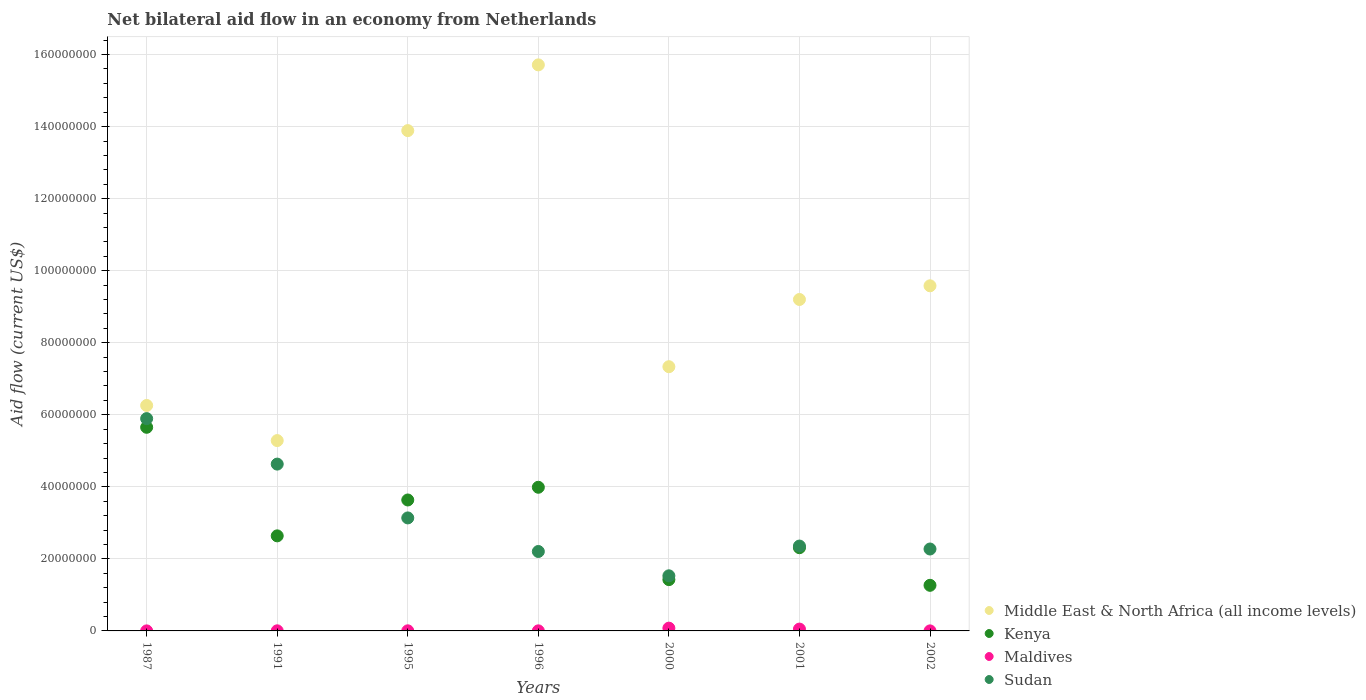How many different coloured dotlines are there?
Give a very brief answer. 4. What is the net bilateral aid flow in Sudan in 1995?
Give a very brief answer. 3.14e+07. Across all years, what is the maximum net bilateral aid flow in Maldives?
Your response must be concise. 7.70e+05. Across all years, what is the minimum net bilateral aid flow in Maldives?
Your answer should be very brief. 10000. What is the total net bilateral aid flow in Kenya in the graph?
Your response must be concise. 2.09e+08. What is the difference between the net bilateral aid flow in Middle East & North Africa (all income levels) in 1995 and that in 2002?
Keep it short and to the point. 4.31e+07. What is the difference between the net bilateral aid flow in Maldives in 2002 and the net bilateral aid flow in Sudan in 2001?
Your answer should be very brief. -2.36e+07. What is the average net bilateral aid flow in Sudan per year?
Your response must be concise. 3.15e+07. In the year 1987, what is the difference between the net bilateral aid flow in Sudan and net bilateral aid flow in Middle East & North Africa (all income levels)?
Provide a succinct answer. -3.65e+06. What is the ratio of the net bilateral aid flow in Middle East & North Africa (all income levels) in 1995 to that in 1996?
Ensure brevity in your answer.  0.88. Is the net bilateral aid flow in Sudan in 1987 less than that in 2002?
Keep it short and to the point. No. Is the difference between the net bilateral aid flow in Sudan in 1991 and 2000 greater than the difference between the net bilateral aid flow in Middle East & North Africa (all income levels) in 1991 and 2000?
Your answer should be very brief. Yes. What is the difference between the highest and the second highest net bilateral aid flow in Middle East & North Africa (all income levels)?
Keep it short and to the point. 1.82e+07. What is the difference between the highest and the lowest net bilateral aid flow in Middle East & North Africa (all income levels)?
Provide a short and direct response. 1.04e+08. Is it the case that in every year, the sum of the net bilateral aid flow in Kenya and net bilateral aid flow in Middle East & North Africa (all income levels)  is greater than the sum of net bilateral aid flow in Maldives and net bilateral aid flow in Sudan?
Provide a succinct answer. No. Is it the case that in every year, the sum of the net bilateral aid flow in Maldives and net bilateral aid flow in Kenya  is greater than the net bilateral aid flow in Sudan?
Ensure brevity in your answer.  No. Does the net bilateral aid flow in Kenya monotonically increase over the years?
Offer a terse response. No. Is the net bilateral aid flow in Kenya strictly less than the net bilateral aid flow in Maldives over the years?
Provide a succinct answer. No. Does the graph contain any zero values?
Provide a succinct answer. No. Where does the legend appear in the graph?
Make the answer very short. Bottom right. How many legend labels are there?
Your answer should be very brief. 4. What is the title of the graph?
Provide a short and direct response. Net bilateral aid flow in an economy from Netherlands. Does "Sudan" appear as one of the legend labels in the graph?
Ensure brevity in your answer.  Yes. What is the label or title of the X-axis?
Keep it short and to the point. Years. What is the Aid flow (current US$) of Middle East & North Africa (all income levels) in 1987?
Provide a short and direct response. 6.26e+07. What is the Aid flow (current US$) of Kenya in 1987?
Provide a short and direct response. 5.65e+07. What is the Aid flow (current US$) in Maldives in 1987?
Provide a short and direct response. 10000. What is the Aid flow (current US$) in Sudan in 1987?
Your answer should be compact. 5.89e+07. What is the Aid flow (current US$) of Middle East & North Africa (all income levels) in 1991?
Offer a terse response. 5.28e+07. What is the Aid flow (current US$) of Kenya in 1991?
Your answer should be compact. 2.64e+07. What is the Aid flow (current US$) of Sudan in 1991?
Make the answer very short. 4.63e+07. What is the Aid flow (current US$) of Middle East & North Africa (all income levels) in 1995?
Make the answer very short. 1.39e+08. What is the Aid flow (current US$) of Kenya in 1995?
Your answer should be compact. 3.64e+07. What is the Aid flow (current US$) of Maldives in 1995?
Provide a short and direct response. 3.00e+04. What is the Aid flow (current US$) in Sudan in 1995?
Provide a succinct answer. 3.14e+07. What is the Aid flow (current US$) in Middle East & North Africa (all income levels) in 1996?
Provide a succinct answer. 1.57e+08. What is the Aid flow (current US$) in Kenya in 1996?
Give a very brief answer. 3.99e+07. What is the Aid flow (current US$) in Maldives in 1996?
Give a very brief answer. 2.00e+04. What is the Aid flow (current US$) in Sudan in 1996?
Ensure brevity in your answer.  2.20e+07. What is the Aid flow (current US$) in Middle East & North Africa (all income levels) in 2000?
Offer a very short reply. 7.34e+07. What is the Aid flow (current US$) of Kenya in 2000?
Your answer should be very brief. 1.42e+07. What is the Aid flow (current US$) of Maldives in 2000?
Keep it short and to the point. 7.70e+05. What is the Aid flow (current US$) in Sudan in 2000?
Provide a succinct answer. 1.53e+07. What is the Aid flow (current US$) in Middle East & North Africa (all income levels) in 2001?
Your answer should be very brief. 9.20e+07. What is the Aid flow (current US$) in Kenya in 2001?
Ensure brevity in your answer.  2.31e+07. What is the Aid flow (current US$) of Maldives in 2001?
Keep it short and to the point. 5.10e+05. What is the Aid flow (current US$) of Sudan in 2001?
Keep it short and to the point. 2.36e+07. What is the Aid flow (current US$) in Middle East & North Africa (all income levels) in 2002?
Offer a terse response. 9.58e+07. What is the Aid flow (current US$) of Kenya in 2002?
Make the answer very short. 1.27e+07. What is the Aid flow (current US$) in Maldives in 2002?
Make the answer very short. 10000. What is the Aid flow (current US$) in Sudan in 2002?
Offer a very short reply. 2.27e+07. Across all years, what is the maximum Aid flow (current US$) of Middle East & North Africa (all income levels)?
Give a very brief answer. 1.57e+08. Across all years, what is the maximum Aid flow (current US$) of Kenya?
Keep it short and to the point. 5.65e+07. Across all years, what is the maximum Aid flow (current US$) of Maldives?
Your answer should be compact. 7.70e+05. Across all years, what is the maximum Aid flow (current US$) in Sudan?
Your answer should be very brief. 5.89e+07. Across all years, what is the minimum Aid flow (current US$) of Middle East & North Africa (all income levels)?
Offer a terse response. 5.28e+07. Across all years, what is the minimum Aid flow (current US$) in Kenya?
Provide a succinct answer. 1.27e+07. Across all years, what is the minimum Aid flow (current US$) in Maldives?
Make the answer very short. 10000. Across all years, what is the minimum Aid flow (current US$) of Sudan?
Ensure brevity in your answer.  1.53e+07. What is the total Aid flow (current US$) of Middle East & North Africa (all income levels) in the graph?
Offer a terse response. 6.73e+08. What is the total Aid flow (current US$) in Kenya in the graph?
Your response must be concise. 2.09e+08. What is the total Aid flow (current US$) in Maldives in the graph?
Your response must be concise. 1.38e+06. What is the total Aid flow (current US$) in Sudan in the graph?
Make the answer very short. 2.20e+08. What is the difference between the Aid flow (current US$) of Middle East & North Africa (all income levels) in 1987 and that in 1991?
Your response must be concise. 9.75e+06. What is the difference between the Aid flow (current US$) of Kenya in 1987 and that in 1991?
Your answer should be very brief. 3.01e+07. What is the difference between the Aid flow (current US$) in Sudan in 1987 and that in 1991?
Keep it short and to the point. 1.26e+07. What is the difference between the Aid flow (current US$) in Middle East & North Africa (all income levels) in 1987 and that in 1995?
Make the answer very short. -7.63e+07. What is the difference between the Aid flow (current US$) in Kenya in 1987 and that in 1995?
Offer a very short reply. 2.02e+07. What is the difference between the Aid flow (current US$) in Maldives in 1987 and that in 1995?
Make the answer very short. -2.00e+04. What is the difference between the Aid flow (current US$) in Sudan in 1987 and that in 1995?
Your answer should be very brief. 2.76e+07. What is the difference between the Aid flow (current US$) in Middle East & North Africa (all income levels) in 1987 and that in 1996?
Your answer should be compact. -9.46e+07. What is the difference between the Aid flow (current US$) of Kenya in 1987 and that in 1996?
Your response must be concise. 1.66e+07. What is the difference between the Aid flow (current US$) in Sudan in 1987 and that in 1996?
Your response must be concise. 3.69e+07. What is the difference between the Aid flow (current US$) of Middle East & North Africa (all income levels) in 1987 and that in 2000?
Make the answer very short. -1.08e+07. What is the difference between the Aid flow (current US$) of Kenya in 1987 and that in 2000?
Offer a terse response. 4.23e+07. What is the difference between the Aid flow (current US$) in Maldives in 1987 and that in 2000?
Keep it short and to the point. -7.60e+05. What is the difference between the Aid flow (current US$) of Sudan in 1987 and that in 2000?
Keep it short and to the point. 4.36e+07. What is the difference between the Aid flow (current US$) of Middle East & North Africa (all income levels) in 1987 and that in 2001?
Your response must be concise. -2.94e+07. What is the difference between the Aid flow (current US$) of Kenya in 1987 and that in 2001?
Ensure brevity in your answer.  3.34e+07. What is the difference between the Aid flow (current US$) of Maldives in 1987 and that in 2001?
Your response must be concise. -5.00e+05. What is the difference between the Aid flow (current US$) in Sudan in 1987 and that in 2001?
Provide a succinct answer. 3.54e+07. What is the difference between the Aid flow (current US$) in Middle East & North Africa (all income levels) in 1987 and that in 2002?
Offer a terse response. -3.32e+07. What is the difference between the Aid flow (current US$) in Kenya in 1987 and that in 2002?
Offer a terse response. 4.39e+07. What is the difference between the Aid flow (current US$) of Maldives in 1987 and that in 2002?
Make the answer very short. 0. What is the difference between the Aid flow (current US$) of Sudan in 1987 and that in 2002?
Your answer should be compact. 3.62e+07. What is the difference between the Aid flow (current US$) in Middle East & North Africa (all income levels) in 1991 and that in 1995?
Make the answer very short. -8.60e+07. What is the difference between the Aid flow (current US$) of Kenya in 1991 and that in 1995?
Ensure brevity in your answer.  -9.96e+06. What is the difference between the Aid flow (current US$) of Maldives in 1991 and that in 1995?
Make the answer very short. 0. What is the difference between the Aid flow (current US$) in Sudan in 1991 and that in 1995?
Provide a succinct answer. 1.49e+07. What is the difference between the Aid flow (current US$) in Middle East & North Africa (all income levels) in 1991 and that in 1996?
Ensure brevity in your answer.  -1.04e+08. What is the difference between the Aid flow (current US$) of Kenya in 1991 and that in 1996?
Provide a short and direct response. -1.35e+07. What is the difference between the Aid flow (current US$) of Sudan in 1991 and that in 1996?
Ensure brevity in your answer.  2.43e+07. What is the difference between the Aid flow (current US$) in Middle East & North Africa (all income levels) in 1991 and that in 2000?
Make the answer very short. -2.05e+07. What is the difference between the Aid flow (current US$) of Kenya in 1991 and that in 2000?
Your answer should be compact. 1.22e+07. What is the difference between the Aid flow (current US$) in Maldives in 1991 and that in 2000?
Your answer should be compact. -7.40e+05. What is the difference between the Aid flow (current US$) in Sudan in 1991 and that in 2000?
Make the answer very short. 3.10e+07. What is the difference between the Aid flow (current US$) of Middle East & North Africa (all income levels) in 1991 and that in 2001?
Ensure brevity in your answer.  -3.92e+07. What is the difference between the Aid flow (current US$) of Kenya in 1991 and that in 2001?
Give a very brief answer. 3.29e+06. What is the difference between the Aid flow (current US$) in Maldives in 1991 and that in 2001?
Your answer should be very brief. -4.80e+05. What is the difference between the Aid flow (current US$) of Sudan in 1991 and that in 2001?
Offer a very short reply. 2.28e+07. What is the difference between the Aid flow (current US$) of Middle East & North Africa (all income levels) in 1991 and that in 2002?
Your response must be concise. -4.30e+07. What is the difference between the Aid flow (current US$) of Kenya in 1991 and that in 2002?
Your answer should be compact. 1.37e+07. What is the difference between the Aid flow (current US$) of Maldives in 1991 and that in 2002?
Your response must be concise. 2.00e+04. What is the difference between the Aid flow (current US$) of Sudan in 1991 and that in 2002?
Your answer should be compact. 2.36e+07. What is the difference between the Aid flow (current US$) in Middle East & North Africa (all income levels) in 1995 and that in 1996?
Ensure brevity in your answer.  -1.82e+07. What is the difference between the Aid flow (current US$) in Kenya in 1995 and that in 1996?
Provide a succinct answer. -3.53e+06. What is the difference between the Aid flow (current US$) of Sudan in 1995 and that in 1996?
Provide a succinct answer. 9.32e+06. What is the difference between the Aid flow (current US$) of Middle East & North Africa (all income levels) in 1995 and that in 2000?
Provide a succinct answer. 6.55e+07. What is the difference between the Aid flow (current US$) in Kenya in 1995 and that in 2000?
Provide a short and direct response. 2.21e+07. What is the difference between the Aid flow (current US$) of Maldives in 1995 and that in 2000?
Keep it short and to the point. -7.40e+05. What is the difference between the Aid flow (current US$) of Sudan in 1995 and that in 2000?
Provide a succinct answer. 1.61e+07. What is the difference between the Aid flow (current US$) of Middle East & North Africa (all income levels) in 1995 and that in 2001?
Your response must be concise. 4.69e+07. What is the difference between the Aid flow (current US$) of Kenya in 1995 and that in 2001?
Offer a very short reply. 1.32e+07. What is the difference between the Aid flow (current US$) of Maldives in 1995 and that in 2001?
Your answer should be compact. -4.80e+05. What is the difference between the Aid flow (current US$) in Sudan in 1995 and that in 2001?
Offer a terse response. 7.81e+06. What is the difference between the Aid flow (current US$) of Middle East & North Africa (all income levels) in 1995 and that in 2002?
Offer a terse response. 4.31e+07. What is the difference between the Aid flow (current US$) of Kenya in 1995 and that in 2002?
Your answer should be very brief. 2.37e+07. What is the difference between the Aid flow (current US$) in Maldives in 1995 and that in 2002?
Your answer should be compact. 2.00e+04. What is the difference between the Aid flow (current US$) in Sudan in 1995 and that in 2002?
Offer a very short reply. 8.63e+06. What is the difference between the Aid flow (current US$) of Middle East & North Africa (all income levels) in 1996 and that in 2000?
Keep it short and to the point. 8.38e+07. What is the difference between the Aid flow (current US$) of Kenya in 1996 and that in 2000?
Keep it short and to the point. 2.56e+07. What is the difference between the Aid flow (current US$) in Maldives in 1996 and that in 2000?
Make the answer very short. -7.50e+05. What is the difference between the Aid flow (current US$) in Sudan in 1996 and that in 2000?
Your answer should be compact. 6.75e+06. What is the difference between the Aid flow (current US$) of Middle East & North Africa (all income levels) in 1996 and that in 2001?
Provide a succinct answer. 6.51e+07. What is the difference between the Aid flow (current US$) in Kenya in 1996 and that in 2001?
Ensure brevity in your answer.  1.68e+07. What is the difference between the Aid flow (current US$) in Maldives in 1996 and that in 2001?
Your response must be concise. -4.90e+05. What is the difference between the Aid flow (current US$) of Sudan in 1996 and that in 2001?
Your answer should be very brief. -1.51e+06. What is the difference between the Aid flow (current US$) of Middle East & North Africa (all income levels) in 1996 and that in 2002?
Your answer should be compact. 6.13e+07. What is the difference between the Aid flow (current US$) of Kenya in 1996 and that in 2002?
Provide a succinct answer. 2.72e+07. What is the difference between the Aid flow (current US$) of Maldives in 1996 and that in 2002?
Keep it short and to the point. 10000. What is the difference between the Aid flow (current US$) of Sudan in 1996 and that in 2002?
Offer a very short reply. -6.90e+05. What is the difference between the Aid flow (current US$) in Middle East & North Africa (all income levels) in 2000 and that in 2001?
Keep it short and to the point. -1.87e+07. What is the difference between the Aid flow (current US$) in Kenya in 2000 and that in 2001?
Your answer should be compact. -8.86e+06. What is the difference between the Aid flow (current US$) in Sudan in 2000 and that in 2001?
Keep it short and to the point. -8.26e+06. What is the difference between the Aid flow (current US$) in Middle East & North Africa (all income levels) in 2000 and that in 2002?
Offer a very short reply. -2.25e+07. What is the difference between the Aid flow (current US$) of Kenya in 2000 and that in 2002?
Your answer should be compact. 1.58e+06. What is the difference between the Aid flow (current US$) in Maldives in 2000 and that in 2002?
Give a very brief answer. 7.60e+05. What is the difference between the Aid flow (current US$) of Sudan in 2000 and that in 2002?
Keep it short and to the point. -7.44e+06. What is the difference between the Aid flow (current US$) in Middle East & North Africa (all income levels) in 2001 and that in 2002?
Ensure brevity in your answer.  -3.80e+06. What is the difference between the Aid flow (current US$) in Kenya in 2001 and that in 2002?
Offer a terse response. 1.04e+07. What is the difference between the Aid flow (current US$) of Sudan in 2001 and that in 2002?
Offer a terse response. 8.20e+05. What is the difference between the Aid flow (current US$) in Middle East & North Africa (all income levels) in 1987 and the Aid flow (current US$) in Kenya in 1991?
Offer a very short reply. 3.62e+07. What is the difference between the Aid flow (current US$) of Middle East & North Africa (all income levels) in 1987 and the Aid flow (current US$) of Maldives in 1991?
Your answer should be very brief. 6.26e+07. What is the difference between the Aid flow (current US$) in Middle East & North Africa (all income levels) in 1987 and the Aid flow (current US$) in Sudan in 1991?
Offer a terse response. 1.63e+07. What is the difference between the Aid flow (current US$) of Kenya in 1987 and the Aid flow (current US$) of Maldives in 1991?
Provide a succinct answer. 5.65e+07. What is the difference between the Aid flow (current US$) of Kenya in 1987 and the Aid flow (current US$) of Sudan in 1991?
Keep it short and to the point. 1.02e+07. What is the difference between the Aid flow (current US$) in Maldives in 1987 and the Aid flow (current US$) in Sudan in 1991?
Offer a very short reply. -4.63e+07. What is the difference between the Aid flow (current US$) in Middle East & North Africa (all income levels) in 1987 and the Aid flow (current US$) in Kenya in 1995?
Keep it short and to the point. 2.62e+07. What is the difference between the Aid flow (current US$) of Middle East & North Africa (all income levels) in 1987 and the Aid flow (current US$) of Maldives in 1995?
Ensure brevity in your answer.  6.26e+07. What is the difference between the Aid flow (current US$) in Middle East & North Africa (all income levels) in 1987 and the Aid flow (current US$) in Sudan in 1995?
Ensure brevity in your answer.  3.12e+07. What is the difference between the Aid flow (current US$) of Kenya in 1987 and the Aid flow (current US$) of Maldives in 1995?
Keep it short and to the point. 5.65e+07. What is the difference between the Aid flow (current US$) of Kenya in 1987 and the Aid flow (current US$) of Sudan in 1995?
Provide a succinct answer. 2.52e+07. What is the difference between the Aid flow (current US$) of Maldives in 1987 and the Aid flow (current US$) of Sudan in 1995?
Ensure brevity in your answer.  -3.14e+07. What is the difference between the Aid flow (current US$) of Middle East & North Africa (all income levels) in 1987 and the Aid flow (current US$) of Kenya in 1996?
Provide a short and direct response. 2.27e+07. What is the difference between the Aid flow (current US$) of Middle East & North Africa (all income levels) in 1987 and the Aid flow (current US$) of Maldives in 1996?
Make the answer very short. 6.26e+07. What is the difference between the Aid flow (current US$) of Middle East & North Africa (all income levels) in 1987 and the Aid flow (current US$) of Sudan in 1996?
Give a very brief answer. 4.05e+07. What is the difference between the Aid flow (current US$) of Kenya in 1987 and the Aid flow (current US$) of Maldives in 1996?
Ensure brevity in your answer.  5.65e+07. What is the difference between the Aid flow (current US$) in Kenya in 1987 and the Aid flow (current US$) in Sudan in 1996?
Offer a terse response. 3.45e+07. What is the difference between the Aid flow (current US$) of Maldives in 1987 and the Aid flow (current US$) of Sudan in 1996?
Offer a terse response. -2.20e+07. What is the difference between the Aid flow (current US$) of Middle East & North Africa (all income levels) in 1987 and the Aid flow (current US$) of Kenya in 2000?
Provide a succinct answer. 4.84e+07. What is the difference between the Aid flow (current US$) of Middle East & North Africa (all income levels) in 1987 and the Aid flow (current US$) of Maldives in 2000?
Offer a terse response. 6.18e+07. What is the difference between the Aid flow (current US$) of Middle East & North Africa (all income levels) in 1987 and the Aid flow (current US$) of Sudan in 2000?
Give a very brief answer. 4.73e+07. What is the difference between the Aid flow (current US$) in Kenya in 1987 and the Aid flow (current US$) in Maldives in 2000?
Make the answer very short. 5.58e+07. What is the difference between the Aid flow (current US$) in Kenya in 1987 and the Aid flow (current US$) in Sudan in 2000?
Offer a terse response. 4.12e+07. What is the difference between the Aid flow (current US$) in Maldives in 1987 and the Aid flow (current US$) in Sudan in 2000?
Provide a succinct answer. -1.53e+07. What is the difference between the Aid flow (current US$) in Middle East & North Africa (all income levels) in 1987 and the Aid flow (current US$) in Kenya in 2001?
Your answer should be very brief. 3.95e+07. What is the difference between the Aid flow (current US$) in Middle East & North Africa (all income levels) in 1987 and the Aid flow (current US$) in Maldives in 2001?
Your response must be concise. 6.21e+07. What is the difference between the Aid flow (current US$) of Middle East & North Africa (all income levels) in 1987 and the Aid flow (current US$) of Sudan in 2001?
Your response must be concise. 3.90e+07. What is the difference between the Aid flow (current US$) of Kenya in 1987 and the Aid flow (current US$) of Maldives in 2001?
Your answer should be very brief. 5.60e+07. What is the difference between the Aid flow (current US$) in Kenya in 1987 and the Aid flow (current US$) in Sudan in 2001?
Provide a succinct answer. 3.30e+07. What is the difference between the Aid flow (current US$) of Maldives in 1987 and the Aid flow (current US$) of Sudan in 2001?
Provide a succinct answer. -2.36e+07. What is the difference between the Aid flow (current US$) in Middle East & North Africa (all income levels) in 1987 and the Aid flow (current US$) in Kenya in 2002?
Your answer should be very brief. 4.99e+07. What is the difference between the Aid flow (current US$) of Middle East & North Africa (all income levels) in 1987 and the Aid flow (current US$) of Maldives in 2002?
Offer a very short reply. 6.26e+07. What is the difference between the Aid flow (current US$) in Middle East & North Africa (all income levels) in 1987 and the Aid flow (current US$) in Sudan in 2002?
Give a very brief answer. 3.98e+07. What is the difference between the Aid flow (current US$) in Kenya in 1987 and the Aid flow (current US$) in Maldives in 2002?
Provide a succinct answer. 5.65e+07. What is the difference between the Aid flow (current US$) in Kenya in 1987 and the Aid flow (current US$) in Sudan in 2002?
Give a very brief answer. 3.38e+07. What is the difference between the Aid flow (current US$) in Maldives in 1987 and the Aid flow (current US$) in Sudan in 2002?
Provide a succinct answer. -2.27e+07. What is the difference between the Aid flow (current US$) of Middle East & North Africa (all income levels) in 1991 and the Aid flow (current US$) of Kenya in 1995?
Provide a short and direct response. 1.65e+07. What is the difference between the Aid flow (current US$) of Middle East & North Africa (all income levels) in 1991 and the Aid flow (current US$) of Maldives in 1995?
Make the answer very short. 5.28e+07. What is the difference between the Aid flow (current US$) of Middle East & North Africa (all income levels) in 1991 and the Aid flow (current US$) of Sudan in 1995?
Your answer should be very brief. 2.15e+07. What is the difference between the Aid flow (current US$) of Kenya in 1991 and the Aid flow (current US$) of Maldives in 1995?
Offer a very short reply. 2.64e+07. What is the difference between the Aid flow (current US$) of Kenya in 1991 and the Aid flow (current US$) of Sudan in 1995?
Offer a very short reply. -4.98e+06. What is the difference between the Aid flow (current US$) of Maldives in 1991 and the Aid flow (current US$) of Sudan in 1995?
Offer a terse response. -3.13e+07. What is the difference between the Aid flow (current US$) of Middle East & North Africa (all income levels) in 1991 and the Aid flow (current US$) of Kenya in 1996?
Your response must be concise. 1.30e+07. What is the difference between the Aid flow (current US$) in Middle East & North Africa (all income levels) in 1991 and the Aid flow (current US$) in Maldives in 1996?
Offer a very short reply. 5.28e+07. What is the difference between the Aid flow (current US$) in Middle East & North Africa (all income levels) in 1991 and the Aid flow (current US$) in Sudan in 1996?
Provide a succinct answer. 3.08e+07. What is the difference between the Aid flow (current US$) in Kenya in 1991 and the Aid flow (current US$) in Maldives in 1996?
Provide a succinct answer. 2.64e+07. What is the difference between the Aid flow (current US$) in Kenya in 1991 and the Aid flow (current US$) in Sudan in 1996?
Ensure brevity in your answer.  4.34e+06. What is the difference between the Aid flow (current US$) in Maldives in 1991 and the Aid flow (current US$) in Sudan in 1996?
Your response must be concise. -2.20e+07. What is the difference between the Aid flow (current US$) of Middle East & North Africa (all income levels) in 1991 and the Aid flow (current US$) of Kenya in 2000?
Provide a succinct answer. 3.86e+07. What is the difference between the Aid flow (current US$) of Middle East & North Africa (all income levels) in 1991 and the Aid flow (current US$) of Maldives in 2000?
Give a very brief answer. 5.21e+07. What is the difference between the Aid flow (current US$) in Middle East & North Africa (all income levels) in 1991 and the Aid flow (current US$) in Sudan in 2000?
Offer a terse response. 3.75e+07. What is the difference between the Aid flow (current US$) of Kenya in 1991 and the Aid flow (current US$) of Maldives in 2000?
Make the answer very short. 2.56e+07. What is the difference between the Aid flow (current US$) in Kenya in 1991 and the Aid flow (current US$) in Sudan in 2000?
Your answer should be very brief. 1.11e+07. What is the difference between the Aid flow (current US$) of Maldives in 1991 and the Aid flow (current US$) of Sudan in 2000?
Give a very brief answer. -1.53e+07. What is the difference between the Aid flow (current US$) of Middle East & North Africa (all income levels) in 1991 and the Aid flow (current US$) of Kenya in 2001?
Provide a short and direct response. 2.97e+07. What is the difference between the Aid flow (current US$) of Middle East & North Africa (all income levels) in 1991 and the Aid flow (current US$) of Maldives in 2001?
Make the answer very short. 5.23e+07. What is the difference between the Aid flow (current US$) of Middle East & North Africa (all income levels) in 1991 and the Aid flow (current US$) of Sudan in 2001?
Provide a succinct answer. 2.93e+07. What is the difference between the Aid flow (current US$) in Kenya in 1991 and the Aid flow (current US$) in Maldives in 2001?
Make the answer very short. 2.59e+07. What is the difference between the Aid flow (current US$) in Kenya in 1991 and the Aid flow (current US$) in Sudan in 2001?
Your response must be concise. 2.83e+06. What is the difference between the Aid flow (current US$) in Maldives in 1991 and the Aid flow (current US$) in Sudan in 2001?
Make the answer very short. -2.35e+07. What is the difference between the Aid flow (current US$) in Middle East & North Africa (all income levels) in 1991 and the Aid flow (current US$) in Kenya in 2002?
Provide a short and direct response. 4.02e+07. What is the difference between the Aid flow (current US$) in Middle East & North Africa (all income levels) in 1991 and the Aid flow (current US$) in Maldives in 2002?
Offer a terse response. 5.28e+07. What is the difference between the Aid flow (current US$) in Middle East & North Africa (all income levels) in 1991 and the Aid flow (current US$) in Sudan in 2002?
Make the answer very short. 3.01e+07. What is the difference between the Aid flow (current US$) in Kenya in 1991 and the Aid flow (current US$) in Maldives in 2002?
Give a very brief answer. 2.64e+07. What is the difference between the Aid flow (current US$) of Kenya in 1991 and the Aid flow (current US$) of Sudan in 2002?
Make the answer very short. 3.65e+06. What is the difference between the Aid flow (current US$) in Maldives in 1991 and the Aid flow (current US$) in Sudan in 2002?
Offer a terse response. -2.27e+07. What is the difference between the Aid flow (current US$) in Middle East & North Africa (all income levels) in 1995 and the Aid flow (current US$) in Kenya in 1996?
Your response must be concise. 9.90e+07. What is the difference between the Aid flow (current US$) of Middle East & North Africa (all income levels) in 1995 and the Aid flow (current US$) of Maldives in 1996?
Offer a very short reply. 1.39e+08. What is the difference between the Aid flow (current US$) in Middle East & North Africa (all income levels) in 1995 and the Aid flow (current US$) in Sudan in 1996?
Your answer should be very brief. 1.17e+08. What is the difference between the Aid flow (current US$) in Kenya in 1995 and the Aid flow (current US$) in Maldives in 1996?
Keep it short and to the point. 3.63e+07. What is the difference between the Aid flow (current US$) in Kenya in 1995 and the Aid flow (current US$) in Sudan in 1996?
Keep it short and to the point. 1.43e+07. What is the difference between the Aid flow (current US$) of Maldives in 1995 and the Aid flow (current US$) of Sudan in 1996?
Your answer should be compact. -2.20e+07. What is the difference between the Aid flow (current US$) of Middle East & North Africa (all income levels) in 1995 and the Aid flow (current US$) of Kenya in 2000?
Your response must be concise. 1.25e+08. What is the difference between the Aid flow (current US$) of Middle East & North Africa (all income levels) in 1995 and the Aid flow (current US$) of Maldives in 2000?
Ensure brevity in your answer.  1.38e+08. What is the difference between the Aid flow (current US$) of Middle East & North Africa (all income levels) in 1995 and the Aid flow (current US$) of Sudan in 2000?
Make the answer very short. 1.24e+08. What is the difference between the Aid flow (current US$) of Kenya in 1995 and the Aid flow (current US$) of Maldives in 2000?
Keep it short and to the point. 3.56e+07. What is the difference between the Aid flow (current US$) in Kenya in 1995 and the Aid flow (current US$) in Sudan in 2000?
Ensure brevity in your answer.  2.10e+07. What is the difference between the Aid flow (current US$) in Maldives in 1995 and the Aid flow (current US$) in Sudan in 2000?
Your response must be concise. -1.53e+07. What is the difference between the Aid flow (current US$) of Middle East & North Africa (all income levels) in 1995 and the Aid flow (current US$) of Kenya in 2001?
Give a very brief answer. 1.16e+08. What is the difference between the Aid flow (current US$) of Middle East & North Africa (all income levels) in 1995 and the Aid flow (current US$) of Maldives in 2001?
Offer a terse response. 1.38e+08. What is the difference between the Aid flow (current US$) in Middle East & North Africa (all income levels) in 1995 and the Aid flow (current US$) in Sudan in 2001?
Offer a very short reply. 1.15e+08. What is the difference between the Aid flow (current US$) of Kenya in 1995 and the Aid flow (current US$) of Maldives in 2001?
Give a very brief answer. 3.58e+07. What is the difference between the Aid flow (current US$) of Kenya in 1995 and the Aid flow (current US$) of Sudan in 2001?
Offer a very short reply. 1.28e+07. What is the difference between the Aid flow (current US$) in Maldives in 1995 and the Aid flow (current US$) in Sudan in 2001?
Your response must be concise. -2.35e+07. What is the difference between the Aid flow (current US$) in Middle East & North Africa (all income levels) in 1995 and the Aid flow (current US$) in Kenya in 2002?
Offer a terse response. 1.26e+08. What is the difference between the Aid flow (current US$) in Middle East & North Africa (all income levels) in 1995 and the Aid flow (current US$) in Maldives in 2002?
Offer a very short reply. 1.39e+08. What is the difference between the Aid flow (current US$) of Middle East & North Africa (all income levels) in 1995 and the Aid flow (current US$) of Sudan in 2002?
Your answer should be very brief. 1.16e+08. What is the difference between the Aid flow (current US$) of Kenya in 1995 and the Aid flow (current US$) of Maldives in 2002?
Your answer should be very brief. 3.63e+07. What is the difference between the Aid flow (current US$) in Kenya in 1995 and the Aid flow (current US$) in Sudan in 2002?
Your response must be concise. 1.36e+07. What is the difference between the Aid flow (current US$) of Maldives in 1995 and the Aid flow (current US$) of Sudan in 2002?
Ensure brevity in your answer.  -2.27e+07. What is the difference between the Aid flow (current US$) in Middle East & North Africa (all income levels) in 1996 and the Aid flow (current US$) in Kenya in 2000?
Provide a short and direct response. 1.43e+08. What is the difference between the Aid flow (current US$) in Middle East & North Africa (all income levels) in 1996 and the Aid flow (current US$) in Maldives in 2000?
Provide a succinct answer. 1.56e+08. What is the difference between the Aid flow (current US$) in Middle East & North Africa (all income levels) in 1996 and the Aid flow (current US$) in Sudan in 2000?
Offer a terse response. 1.42e+08. What is the difference between the Aid flow (current US$) in Kenya in 1996 and the Aid flow (current US$) in Maldives in 2000?
Provide a succinct answer. 3.91e+07. What is the difference between the Aid flow (current US$) of Kenya in 1996 and the Aid flow (current US$) of Sudan in 2000?
Offer a terse response. 2.46e+07. What is the difference between the Aid flow (current US$) in Maldives in 1996 and the Aid flow (current US$) in Sudan in 2000?
Offer a terse response. -1.53e+07. What is the difference between the Aid flow (current US$) in Middle East & North Africa (all income levels) in 1996 and the Aid flow (current US$) in Kenya in 2001?
Give a very brief answer. 1.34e+08. What is the difference between the Aid flow (current US$) in Middle East & North Africa (all income levels) in 1996 and the Aid flow (current US$) in Maldives in 2001?
Give a very brief answer. 1.57e+08. What is the difference between the Aid flow (current US$) of Middle East & North Africa (all income levels) in 1996 and the Aid flow (current US$) of Sudan in 2001?
Keep it short and to the point. 1.34e+08. What is the difference between the Aid flow (current US$) in Kenya in 1996 and the Aid flow (current US$) in Maldives in 2001?
Offer a very short reply. 3.94e+07. What is the difference between the Aid flow (current US$) of Kenya in 1996 and the Aid flow (current US$) of Sudan in 2001?
Give a very brief answer. 1.63e+07. What is the difference between the Aid flow (current US$) of Maldives in 1996 and the Aid flow (current US$) of Sudan in 2001?
Ensure brevity in your answer.  -2.35e+07. What is the difference between the Aid flow (current US$) of Middle East & North Africa (all income levels) in 1996 and the Aid flow (current US$) of Kenya in 2002?
Keep it short and to the point. 1.44e+08. What is the difference between the Aid flow (current US$) in Middle East & North Africa (all income levels) in 1996 and the Aid flow (current US$) in Maldives in 2002?
Offer a very short reply. 1.57e+08. What is the difference between the Aid flow (current US$) in Middle East & North Africa (all income levels) in 1996 and the Aid flow (current US$) in Sudan in 2002?
Your answer should be very brief. 1.34e+08. What is the difference between the Aid flow (current US$) of Kenya in 1996 and the Aid flow (current US$) of Maldives in 2002?
Provide a short and direct response. 3.99e+07. What is the difference between the Aid flow (current US$) of Kenya in 1996 and the Aid flow (current US$) of Sudan in 2002?
Make the answer very short. 1.71e+07. What is the difference between the Aid flow (current US$) of Maldives in 1996 and the Aid flow (current US$) of Sudan in 2002?
Your answer should be very brief. -2.27e+07. What is the difference between the Aid flow (current US$) in Middle East & North Africa (all income levels) in 2000 and the Aid flow (current US$) in Kenya in 2001?
Keep it short and to the point. 5.02e+07. What is the difference between the Aid flow (current US$) in Middle East & North Africa (all income levels) in 2000 and the Aid flow (current US$) in Maldives in 2001?
Your answer should be compact. 7.28e+07. What is the difference between the Aid flow (current US$) of Middle East & North Africa (all income levels) in 2000 and the Aid flow (current US$) of Sudan in 2001?
Your answer should be compact. 4.98e+07. What is the difference between the Aid flow (current US$) of Kenya in 2000 and the Aid flow (current US$) of Maldives in 2001?
Your response must be concise. 1.37e+07. What is the difference between the Aid flow (current US$) of Kenya in 2000 and the Aid flow (current US$) of Sudan in 2001?
Offer a terse response. -9.32e+06. What is the difference between the Aid flow (current US$) of Maldives in 2000 and the Aid flow (current US$) of Sudan in 2001?
Offer a very short reply. -2.28e+07. What is the difference between the Aid flow (current US$) of Middle East & North Africa (all income levels) in 2000 and the Aid flow (current US$) of Kenya in 2002?
Keep it short and to the point. 6.07e+07. What is the difference between the Aid flow (current US$) of Middle East & North Africa (all income levels) in 2000 and the Aid flow (current US$) of Maldives in 2002?
Your answer should be very brief. 7.33e+07. What is the difference between the Aid flow (current US$) in Middle East & North Africa (all income levels) in 2000 and the Aid flow (current US$) in Sudan in 2002?
Give a very brief answer. 5.06e+07. What is the difference between the Aid flow (current US$) in Kenya in 2000 and the Aid flow (current US$) in Maldives in 2002?
Give a very brief answer. 1.42e+07. What is the difference between the Aid flow (current US$) of Kenya in 2000 and the Aid flow (current US$) of Sudan in 2002?
Provide a succinct answer. -8.50e+06. What is the difference between the Aid flow (current US$) of Maldives in 2000 and the Aid flow (current US$) of Sudan in 2002?
Ensure brevity in your answer.  -2.20e+07. What is the difference between the Aid flow (current US$) in Middle East & North Africa (all income levels) in 2001 and the Aid flow (current US$) in Kenya in 2002?
Give a very brief answer. 7.94e+07. What is the difference between the Aid flow (current US$) of Middle East & North Africa (all income levels) in 2001 and the Aid flow (current US$) of Maldives in 2002?
Provide a short and direct response. 9.20e+07. What is the difference between the Aid flow (current US$) in Middle East & North Africa (all income levels) in 2001 and the Aid flow (current US$) in Sudan in 2002?
Ensure brevity in your answer.  6.93e+07. What is the difference between the Aid flow (current US$) in Kenya in 2001 and the Aid flow (current US$) in Maldives in 2002?
Make the answer very short. 2.31e+07. What is the difference between the Aid flow (current US$) of Maldives in 2001 and the Aid flow (current US$) of Sudan in 2002?
Provide a succinct answer. -2.22e+07. What is the average Aid flow (current US$) in Middle East & North Africa (all income levels) per year?
Offer a terse response. 9.61e+07. What is the average Aid flow (current US$) of Kenya per year?
Ensure brevity in your answer.  2.99e+07. What is the average Aid flow (current US$) in Maldives per year?
Keep it short and to the point. 1.97e+05. What is the average Aid flow (current US$) in Sudan per year?
Give a very brief answer. 3.15e+07. In the year 1987, what is the difference between the Aid flow (current US$) of Middle East & North Africa (all income levels) and Aid flow (current US$) of Kenya?
Keep it short and to the point. 6.06e+06. In the year 1987, what is the difference between the Aid flow (current US$) of Middle East & North Africa (all income levels) and Aid flow (current US$) of Maldives?
Ensure brevity in your answer.  6.26e+07. In the year 1987, what is the difference between the Aid flow (current US$) in Middle East & North Africa (all income levels) and Aid flow (current US$) in Sudan?
Keep it short and to the point. 3.65e+06. In the year 1987, what is the difference between the Aid flow (current US$) in Kenya and Aid flow (current US$) in Maldives?
Your response must be concise. 5.65e+07. In the year 1987, what is the difference between the Aid flow (current US$) in Kenya and Aid flow (current US$) in Sudan?
Make the answer very short. -2.41e+06. In the year 1987, what is the difference between the Aid flow (current US$) of Maldives and Aid flow (current US$) of Sudan?
Give a very brief answer. -5.89e+07. In the year 1991, what is the difference between the Aid flow (current US$) in Middle East & North Africa (all income levels) and Aid flow (current US$) in Kenya?
Give a very brief answer. 2.64e+07. In the year 1991, what is the difference between the Aid flow (current US$) of Middle East & North Africa (all income levels) and Aid flow (current US$) of Maldives?
Your answer should be very brief. 5.28e+07. In the year 1991, what is the difference between the Aid flow (current US$) of Middle East & North Africa (all income levels) and Aid flow (current US$) of Sudan?
Offer a terse response. 6.53e+06. In the year 1991, what is the difference between the Aid flow (current US$) in Kenya and Aid flow (current US$) in Maldives?
Your answer should be very brief. 2.64e+07. In the year 1991, what is the difference between the Aid flow (current US$) in Kenya and Aid flow (current US$) in Sudan?
Your answer should be very brief. -1.99e+07. In the year 1991, what is the difference between the Aid flow (current US$) in Maldives and Aid flow (current US$) in Sudan?
Provide a succinct answer. -4.63e+07. In the year 1995, what is the difference between the Aid flow (current US$) in Middle East & North Africa (all income levels) and Aid flow (current US$) in Kenya?
Provide a short and direct response. 1.03e+08. In the year 1995, what is the difference between the Aid flow (current US$) in Middle East & North Africa (all income levels) and Aid flow (current US$) in Maldives?
Provide a short and direct response. 1.39e+08. In the year 1995, what is the difference between the Aid flow (current US$) in Middle East & North Africa (all income levels) and Aid flow (current US$) in Sudan?
Keep it short and to the point. 1.08e+08. In the year 1995, what is the difference between the Aid flow (current US$) of Kenya and Aid flow (current US$) of Maldives?
Make the answer very short. 3.63e+07. In the year 1995, what is the difference between the Aid flow (current US$) of Kenya and Aid flow (current US$) of Sudan?
Give a very brief answer. 4.98e+06. In the year 1995, what is the difference between the Aid flow (current US$) of Maldives and Aid flow (current US$) of Sudan?
Provide a short and direct response. -3.13e+07. In the year 1996, what is the difference between the Aid flow (current US$) of Middle East & North Africa (all income levels) and Aid flow (current US$) of Kenya?
Your response must be concise. 1.17e+08. In the year 1996, what is the difference between the Aid flow (current US$) in Middle East & North Africa (all income levels) and Aid flow (current US$) in Maldives?
Give a very brief answer. 1.57e+08. In the year 1996, what is the difference between the Aid flow (current US$) of Middle East & North Africa (all income levels) and Aid flow (current US$) of Sudan?
Your answer should be very brief. 1.35e+08. In the year 1996, what is the difference between the Aid flow (current US$) in Kenya and Aid flow (current US$) in Maldives?
Make the answer very short. 3.99e+07. In the year 1996, what is the difference between the Aid flow (current US$) in Kenya and Aid flow (current US$) in Sudan?
Offer a terse response. 1.78e+07. In the year 1996, what is the difference between the Aid flow (current US$) in Maldives and Aid flow (current US$) in Sudan?
Your answer should be compact. -2.20e+07. In the year 2000, what is the difference between the Aid flow (current US$) in Middle East & North Africa (all income levels) and Aid flow (current US$) in Kenya?
Provide a succinct answer. 5.91e+07. In the year 2000, what is the difference between the Aid flow (current US$) of Middle East & North Africa (all income levels) and Aid flow (current US$) of Maldives?
Provide a succinct answer. 7.26e+07. In the year 2000, what is the difference between the Aid flow (current US$) of Middle East & North Africa (all income levels) and Aid flow (current US$) of Sudan?
Keep it short and to the point. 5.80e+07. In the year 2000, what is the difference between the Aid flow (current US$) of Kenya and Aid flow (current US$) of Maldives?
Offer a very short reply. 1.35e+07. In the year 2000, what is the difference between the Aid flow (current US$) of Kenya and Aid flow (current US$) of Sudan?
Your answer should be compact. -1.06e+06. In the year 2000, what is the difference between the Aid flow (current US$) of Maldives and Aid flow (current US$) of Sudan?
Your answer should be very brief. -1.45e+07. In the year 2001, what is the difference between the Aid flow (current US$) in Middle East & North Africa (all income levels) and Aid flow (current US$) in Kenya?
Give a very brief answer. 6.89e+07. In the year 2001, what is the difference between the Aid flow (current US$) in Middle East & North Africa (all income levels) and Aid flow (current US$) in Maldives?
Your answer should be very brief. 9.15e+07. In the year 2001, what is the difference between the Aid flow (current US$) of Middle East & North Africa (all income levels) and Aid flow (current US$) of Sudan?
Your answer should be compact. 6.84e+07. In the year 2001, what is the difference between the Aid flow (current US$) of Kenya and Aid flow (current US$) of Maldives?
Make the answer very short. 2.26e+07. In the year 2001, what is the difference between the Aid flow (current US$) in Kenya and Aid flow (current US$) in Sudan?
Offer a terse response. -4.60e+05. In the year 2001, what is the difference between the Aid flow (current US$) of Maldives and Aid flow (current US$) of Sudan?
Provide a succinct answer. -2.30e+07. In the year 2002, what is the difference between the Aid flow (current US$) of Middle East & North Africa (all income levels) and Aid flow (current US$) of Kenya?
Offer a very short reply. 8.32e+07. In the year 2002, what is the difference between the Aid flow (current US$) of Middle East & North Africa (all income levels) and Aid flow (current US$) of Maldives?
Your answer should be compact. 9.58e+07. In the year 2002, what is the difference between the Aid flow (current US$) of Middle East & North Africa (all income levels) and Aid flow (current US$) of Sudan?
Your response must be concise. 7.31e+07. In the year 2002, what is the difference between the Aid flow (current US$) in Kenya and Aid flow (current US$) in Maldives?
Your answer should be compact. 1.26e+07. In the year 2002, what is the difference between the Aid flow (current US$) in Kenya and Aid flow (current US$) in Sudan?
Provide a succinct answer. -1.01e+07. In the year 2002, what is the difference between the Aid flow (current US$) in Maldives and Aid flow (current US$) in Sudan?
Ensure brevity in your answer.  -2.27e+07. What is the ratio of the Aid flow (current US$) in Middle East & North Africa (all income levels) in 1987 to that in 1991?
Offer a terse response. 1.18. What is the ratio of the Aid flow (current US$) of Kenya in 1987 to that in 1991?
Your answer should be very brief. 2.14. What is the ratio of the Aid flow (current US$) of Maldives in 1987 to that in 1991?
Provide a succinct answer. 0.33. What is the ratio of the Aid flow (current US$) of Sudan in 1987 to that in 1991?
Your response must be concise. 1.27. What is the ratio of the Aid flow (current US$) of Middle East & North Africa (all income levels) in 1987 to that in 1995?
Make the answer very short. 0.45. What is the ratio of the Aid flow (current US$) in Kenya in 1987 to that in 1995?
Make the answer very short. 1.56. What is the ratio of the Aid flow (current US$) of Maldives in 1987 to that in 1995?
Offer a terse response. 0.33. What is the ratio of the Aid flow (current US$) of Sudan in 1987 to that in 1995?
Offer a terse response. 1.88. What is the ratio of the Aid flow (current US$) in Middle East & North Africa (all income levels) in 1987 to that in 1996?
Ensure brevity in your answer.  0.4. What is the ratio of the Aid flow (current US$) in Kenya in 1987 to that in 1996?
Give a very brief answer. 1.42. What is the ratio of the Aid flow (current US$) in Maldives in 1987 to that in 1996?
Your response must be concise. 0.5. What is the ratio of the Aid flow (current US$) of Sudan in 1987 to that in 1996?
Offer a terse response. 2.67. What is the ratio of the Aid flow (current US$) of Middle East & North Africa (all income levels) in 1987 to that in 2000?
Offer a terse response. 0.85. What is the ratio of the Aid flow (current US$) in Kenya in 1987 to that in 2000?
Offer a terse response. 3.97. What is the ratio of the Aid flow (current US$) in Maldives in 1987 to that in 2000?
Provide a succinct answer. 0.01. What is the ratio of the Aid flow (current US$) in Sudan in 1987 to that in 2000?
Give a very brief answer. 3.85. What is the ratio of the Aid flow (current US$) in Middle East & North Africa (all income levels) in 1987 to that in 2001?
Provide a short and direct response. 0.68. What is the ratio of the Aid flow (current US$) of Kenya in 1987 to that in 2001?
Keep it short and to the point. 2.45. What is the ratio of the Aid flow (current US$) in Maldives in 1987 to that in 2001?
Your answer should be compact. 0.02. What is the ratio of the Aid flow (current US$) of Sudan in 1987 to that in 2001?
Give a very brief answer. 2.5. What is the ratio of the Aid flow (current US$) of Middle East & North Africa (all income levels) in 1987 to that in 2002?
Make the answer very short. 0.65. What is the ratio of the Aid flow (current US$) in Kenya in 1987 to that in 2002?
Your answer should be very brief. 4.47. What is the ratio of the Aid flow (current US$) of Maldives in 1987 to that in 2002?
Ensure brevity in your answer.  1. What is the ratio of the Aid flow (current US$) in Sudan in 1987 to that in 2002?
Keep it short and to the point. 2.59. What is the ratio of the Aid flow (current US$) in Middle East & North Africa (all income levels) in 1991 to that in 1995?
Make the answer very short. 0.38. What is the ratio of the Aid flow (current US$) of Kenya in 1991 to that in 1995?
Provide a succinct answer. 0.73. What is the ratio of the Aid flow (current US$) of Maldives in 1991 to that in 1995?
Ensure brevity in your answer.  1. What is the ratio of the Aid flow (current US$) in Sudan in 1991 to that in 1995?
Your answer should be compact. 1.48. What is the ratio of the Aid flow (current US$) in Middle East & North Africa (all income levels) in 1991 to that in 1996?
Give a very brief answer. 0.34. What is the ratio of the Aid flow (current US$) of Kenya in 1991 to that in 1996?
Offer a very short reply. 0.66. What is the ratio of the Aid flow (current US$) in Maldives in 1991 to that in 1996?
Make the answer very short. 1.5. What is the ratio of the Aid flow (current US$) of Sudan in 1991 to that in 1996?
Your response must be concise. 2.1. What is the ratio of the Aid flow (current US$) in Middle East & North Africa (all income levels) in 1991 to that in 2000?
Provide a short and direct response. 0.72. What is the ratio of the Aid flow (current US$) in Kenya in 1991 to that in 2000?
Your answer should be very brief. 1.85. What is the ratio of the Aid flow (current US$) of Maldives in 1991 to that in 2000?
Offer a terse response. 0.04. What is the ratio of the Aid flow (current US$) of Sudan in 1991 to that in 2000?
Offer a very short reply. 3.03. What is the ratio of the Aid flow (current US$) of Middle East & North Africa (all income levels) in 1991 to that in 2001?
Your answer should be compact. 0.57. What is the ratio of the Aid flow (current US$) of Kenya in 1991 to that in 2001?
Your response must be concise. 1.14. What is the ratio of the Aid flow (current US$) in Maldives in 1991 to that in 2001?
Offer a very short reply. 0.06. What is the ratio of the Aid flow (current US$) of Sudan in 1991 to that in 2001?
Your answer should be very brief. 1.97. What is the ratio of the Aid flow (current US$) in Middle East & North Africa (all income levels) in 1991 to that in 2002?
Offer a terse response. 0.55. What is the ratio of the Aid flow (current US$) of Kenya in 1991 to that in 2002?
Provide a succinct answer. 2.08. What is the ratio of the Aid flow (current US$) of Maldives in 1991 to that in 2002?
Your answer should be very brief. 3. What is the ratio of the Aid flow (current US$) of Sudan in 1991 to that in 2002?
Make the answer very short. 2.04. What is the ratio of the Aid flow (current US$) of Middle East & North Africa (all income levels) in 1995 to that in 1996?
Keep it short and to the point. 0.88. What is the ratio of the Aid flow (current US$) in Kenya in 1995 to that in 1996?
Provide a succinct answer. 0.91. What is the ratio of the Aid flow (current US$) of Maldives in 1995 to that in 1996?
Your response must be concise. 1.5. What is the ratio of the Aid flow (current US$) in Sudan in 1995 to that in 1996?
Offer a very short reply. 1.42. What is the ratio of the Aid flow (current US$) in Middle East & North Africa (all income levels) in 1995 to that in 2000?
Make the answer very short. 1.89. What is the ratio of the Aid flow (current US$) in Kenya in 1995 to that in 2000?
Make the answer very short. 2.55. What is the ratio of the Aid flow (current US$) in Maldives in 1995 to that in 2000?
Your answer should be compact. 0.04. What is the ratio of the Aid flow (current US$) in Sudan in 1995 to that in 2000?
Ensure brevity in your answer.  2.05. What is the ratio of the Aid flow (current US$) in Middle East & North Africa (all income levels) in 1995 to that in 2001?
Provide a succinct answer. 1.51. What is the ratio of the Aid flow (current US$) of Kenya in 1995 to that in 2001?
Offer a very short reply. 1.57. What is the ratio of the Aid flow (current US$) in Maldives in 1995 to that in 2001?
Keep it short and to the point. 0.06. What is the ratio of the Aid flow (current US$) of Sudan in 1995 to that in 2001?
Your response must be concise. 1.33. What is the ratio of the Aid flow (current US$) in Middle East & North Africa (all income levels) in 1995 to that in 2002?
Ensure brevity in your answer.  1.45. What is the ratio of the Aid flow (current US$) of Kenya in 1995 to that in 2002?
Your answer should be compact. 2.87. What is the ratio of the Aid flow (current US$) of Maldives in 1995 to that in 2002?
Your answer should be very brief. 3. What is the ratio of the Aid flow (current US$) in Sudan in 1995 to that in 2002?
Your answer should be compact. 1.38. What is the ratio of the Aid flow (current US$) of Middle East & North Africa (all income levels) in 1996 to that in 2000?
Ensure brevity in your answer.  2.14. What is the ratio of the Aid flow (current US$) in Kenya in 1996 to that in 2000?
Provide a short and direct response. 2.8. What is the ratio of the Aid flow (current US$) of Maldives in 1996 to that in 2000?
Offer a terse response. 0.03. What is the ratio of the Aid flow (current US$) in Sudan in 1996 to that in 2000?
Your answer should be very brief. 1.44. What is the ratio of the Aid flow (current US$) of Middle East & North Africa (all income levels) in 1996 to that in 2001?
Ensure brevity in your answer.  1.71. What is the ratio of the Aid flow (current US$) of Kenya in 1996 to that in 2001?
Make the answer very short. 1.73. What is the ratio of the Aid flow (current US$) of Maldives in 1996 to that in 2001?
Your answer should be compact. 0.04. What is the ratio of the Aid flow (current US$) of Sudan in 1996 to that in 2001?
Offer a very short reply. 0.94. What is the ratio of the Aid flow (current US$) in Middle East & North Africa (all income levels) in 1996 to that in 2002?
Your response must be concise. 1.64. What is the ratio of the Aid flow (current US$) in Kenya in 1996 to that in 2002?
Your response must be concise. 3.15. What is the ratio of the Aid flow (current US$) of Sudan in 1996 to that in 2002?
Keep it short and to the point. 0.97. What is the ratio of the Aid flow (current US$) in Middle East & North Africa (all income levels) in 2000 to that in 2001?
Your response must be concise. 0.8. What is the ratio of the Aid flow (current US$) in Kenya in 2000 to that in 2001?
Your response must be concise. 0.62. What is the ratio of the Aid flow (current US$) in Maldives in 2000 to that in 2001?
Your answer should be very brief. 1.51. What is the ratio of the Aid flow (current US$) of Sudan in 2000 to that in 2001?
Provide a succinct answer. 0.65. What is the ratio of the Aid flow (current US$) in Middle East & North Africa (all income levels) in 2000 to that in 2002?
Provide a succinct answer. 0.77. What is the ratio of the Aid flow (current US$) in Kenya in 2000 to that in 2002?
Ensure brevity in your answer.  1.12. What is the ratio of the Aid flow (current US$) in Sudan in 2000 to that in 2002?
Your answer should be very brief. 0.67. What is the ratio of the Aid flow (current US$) of Middle East & North Africa (all income levels) in 2001 to that in 2002?
Provide a succinct answer. 0.96. What is the ratio of the Aid flow (current US$) of Kenya in 2001 to that in 2002?
Provide a succinct answer. 1.82. What is the ratio of the Aid flow (current US$) in Sudan in 2001 to that in 2002?
Offer a very short reply. 1.04. What is the difference between the highest and the second highest Aid flow (current US$) of Middle East & North Africa (all income levels)?
Provide a succinct answer. 1.82e+07. What is the difference between the highest and the second highest Aid flow (current US$) in Kenya?
Offer a very short reply. 1.66e+07. What is the difference between the highest and the second highest Aid flow (current US$) of Sudan?
Give a very brief answer. 1.26e+07. What is the difference between the highest and the lowest Aid flow (current US$) of Middle East & North Africa (all income levels)?
Offer a terse response. 1.04e+08. What is the difference between the highest and the lowest Aid flow (current US$) of Kenya?
Make the answer very short. 4.39e+07. What is the difference between the highest and the lowest Aid flow (current US$) in Maldives?
Keep it short and to the point. 7.60e+05. What is the difference between the highest and the lowest Aid flow (current US$) of Sudan?
Offer a terse response. 4.36e+07. 